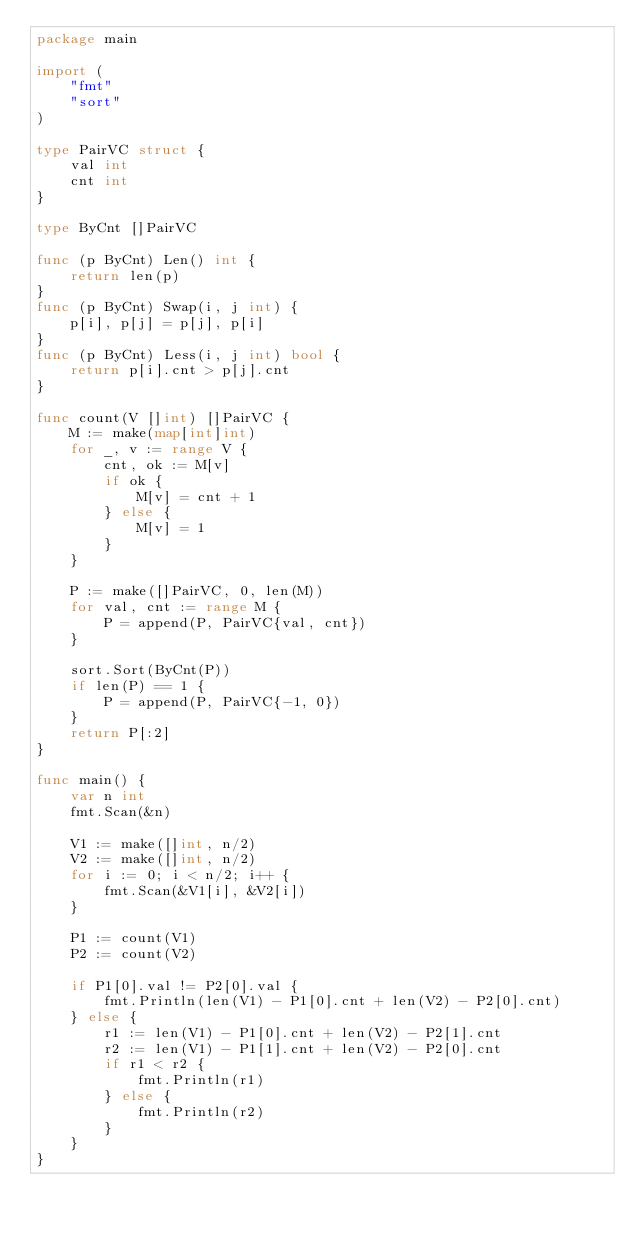Convert code to text. <code><loc_0><loc_0><loc_500><loc_500><_Go_>package main

import (
	"fmt"
	"sort"
)

type PairVC struct {
	val int
	cnt int
}

type ByCnt []PairVC

func (p ByCnt) Len() int {
	return len(p)
}
func (p ByCnt) Swap(i, j int) {
	p[i], p[j] = p[j], p[i]
}
func (p ByCnt) Less(i, j int) bool {
	return p[i].cnt > p[j].cnt
}

func count(V []int) []PairVC {
	M := make(map[int]int)
	for _, v := range V {
		cnt, ok := M[v]
		if ok {
			M[v] = cnt + 1
		} else {
			M[v] = 1
		}
	}

	P := make([]PairVC, 0, len(M))
	for val, cnt := range M {
		P = append(P, PairVC{val, cnt})
	}

	sort.Sort(ByCnt(P))
	if len(P) == 1 {
		P = append(P, PairVC{-1, 0})
	}
	return P[:2]
}

func main() {
	var n int
	fmt.Scan(&n)

	V1 := make([]int, n/2)
	V2 := make([]int, n/2)
	for i := 0; i < n/2; i++ {
		fmt.Scan(&V1[i], &V2[i])
	}

	P1 := count(V1)
	P2 := count(V2)

	if P1[0].val != P2[0].val {
		fmt.Println(len(V1) - P1[0].cnt + len(V2) - P2[0].cnt)
	} else {
		r1 := len(V1) - P1[0].cnt + len(V2) - P2[1].cnt
		r2 := len(V1) - P1[1].cnt + len(V2) - P2[0].cnt
		if r1 < r2 {
			fmt.Println(r1)
		} else {
			fmt.Println(r2)
		}
	}
}
</code> 